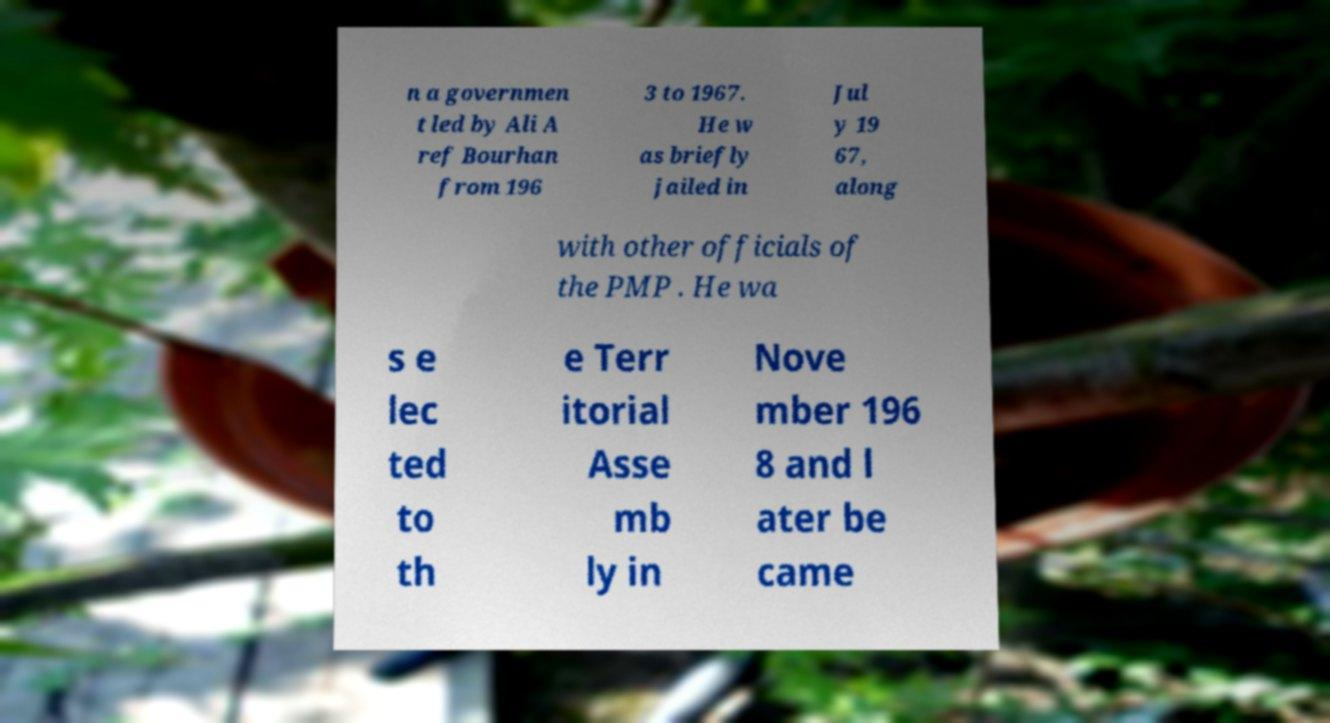Could you extract and type out the text from this image? n a governmen t led by Ali A ref Bourhan from 196 3 to 1967. He w as briefly jailed in Jul y 19 67, along with other officials of the PMP . He wa s e lec ted to th e Terr itorial Asse mb ly in Nove mber 196 8 and l ater be came 